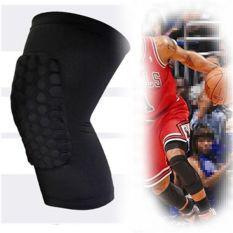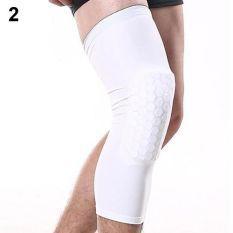The first image is the image on the left, the second image is the image on the right. Assess this claim about the two images: "An image shows a pair of legs with one one leg wearing a knee wrap.". Correct or not? Answer yes or no. Yes. The first image is the image on the left, the second image is the image on the right. Analyze the images presented: Is the assertion "The left image is one black brace, the right image is one white brace." valid? Answer yes or no. Yes. 